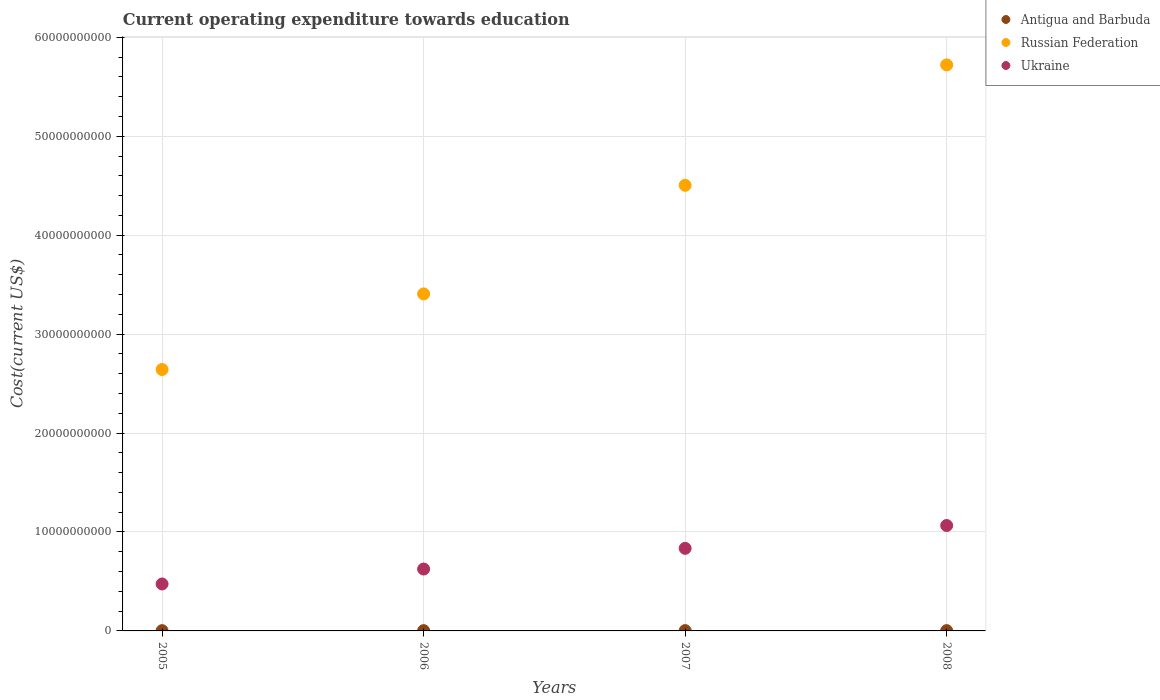How many different coloured dotlines are there?
Provide a succinct answer. 3. Is the number of dotlines equal to the number of legend labels?
Offer a terse response. Yes. What is the expenditure towards education in Russian Federation in 2007?
Your answer should be compact. 4.50e+1. Across all years, what is the maximum expenditure towards education in Antigua and Barbuda?
Provide a succinct answer. 3.09e+07. Across all years, what is the minimum expenditure towards education in Ukraine?
Offer a terse response. 4.75e+09. In which year was the expenditure towards education in Antigua and Barbuda maximum?
Offer a very short reply. 2007. In which year was the expenditure towards education in Russian Federation minimum?
Offer a terse response. 2005. What is the total expenditure towards education in Antigua and Barbuda in the graph?
Provide a short and direct response. 1.18e+08. What is the difference between the expenditure towards education in Antigua and Barbuda in 2005 and that in 2006?
Your answer should be compact. -1.68e+06. What is the difference between the expenditure towards education in Russian Federation in 2006 and the expenditure towards education in Ukraine in 2007?
Ensure brevity in your answer.  2.57e+1. What is the average expenditure towards education in Ukraine per year?
Keep it short and to the point. 7.50e+09. In the year 2005, what is the difference between the expenditure towards education in Antigua and Barbuda and expenditure towards education in Russian Federation?
Your response must be concise. -2.64e+1. What is the ratio of the expenditure towards education in Ukraine in 2005 to that in 2007?
Provide a succinct answer. 0.57. Is the expenditure towards education in Russian Federation in 2005 less than that in 2008?
Offer a very short reply. Yes. Is the difference between the expenditure towards education in Antigua and Barbuda in 2006 and 2008 greater than the difference between the expenditure towards education in Russian Federation in 2006 and 2008?
Offer a very short reply. Yes. What is the difference between the highest and the second highest expenditure towards education in Antigua and Barbuda?
Provide a succinct answer. 1.33e+06. What is the difference between the highest and the lowest expenditure towards education in Ukraine?
Ensure brevity in your answer.  5.91e+09. Is it the case that in every year, the sum of the expenditure towards education in Antigua and Barbuda and expenditure towards education in Russian Federation  is greater than the expenditure towards education in Ukraine?
Keep it short and to the point. Yes. Does the expenditure towards education in Russian Federation monotonically increase over the years?
Provide a succinct answer. Yes. Is the expenditure towards education in Ukraine strictly less than the expenditure towards education in Russian Federation over the years?
Your answer should be very brief. Yes. How many years are there in the graph?
Provide a short and direct response. 4. Where does the legend appear in the graph?
Make the answer very short. Top right. How many legend labels are there?
Offer a very short reply. 3. How are the legend labels stacked?
Give a very brief answer. Vertical. What is the title of the graph?
Make the answer very short. Current operating expenditure towards education. What is the label or title of the Y-axis?
Your response must be concise. Cost(current US$). What is the Cost(current US$) of Antigua and Barbuda in 2005?
Provide a succinct answer. 2.77e+07. What is the Cost(current US$) of Russian Federation in 2005?
Offer a terse response. 2.64e+1. What is the Cost(current US$) of Ukraine in 2005?
Your answer should be very brief. 4.75e+09. What is the Cost(current US$) of Antigua and Barbuda in 2006?
Your answer should be very brief. 2.94e+07. What is the Cost(current US$) in Russian Federation in 2006?
Provide a succinct answer. 3.41e+1. What is the Cost(current US$) of Ukraine in 2006?
Offer a terse response. 6.26e+09. What is the Cost(current US$) of Antigua and Barbuda in 2007?
Offer a terse response. 3.09e+07. What is the Cost(current US$) in Russian Federation in 2007?
Provide a succinct answer. 4.50e+1. What is the Cost(current US$) of Ukraine in 2007?
Keep it short and to the point. 8.35e+09. What is the Cost(current US$) in Antigua and Barbuda in 2008?
Offer a terse response. 2.96e+07. What is the Cost(current US$) in Russian Federation in 2008?
Your answer should be compact. 5.72e+1. What is the Cost(current US$) in Ukraine in 2008?
Provide a succinct answer. 1.07e+1. Across all years, what is the maximum Cost(current US$) in Antigua and Barbuda?
Ensure brevity in your answer.  3.09e+07. Across all years, what is the maximum Cost(current US$) of Russian Federation?
Your answer should be compact. 5.72e+1. Across all years, what is the maximum Cost(current US$) in Ukraine?
Give a very brief answer. 1.07e+1. Across all years, what is the minimum Cost(current US$) of Antigua and Barbuda?
Your response must be concise. 2.77e+07. Across all years, what is the minimum Cost(current US$) in Russian Federation?
Provide a short and direct response. 2.64e+1. Across all years, what is the minimum Cost(current US$) in Ukraine?
Provide a short and direct response. 4.75e+09. What is the total Cost(current US$) of Antigua and Barbuda in the graph?
Your response must be concise. 1.18e+08. What is the total Cost(current US$) of Russian Federation in the graph?
Provide a short and direct response. 1.63e+11. What is the total Cost(current US$) in Ukraine in the graph?
Offer a very short reply. 3.00e+1. What is the difference between the Cost(current US$) in Antigua and Barbuda in 2005 and that in 2006?
Offer a very short reply. -1.68e+06. What is the difference between the Cost(current US$) in Russian Federation in 2005 and that in 2006?
Offer a very short reply. -7.64e+09. What is the difference between the Cost(current US$) of Ukraine in 2005 and that in 2006?
Offer a very short reply. -1.51e+09. What is the difference between the Cost(current US$) in Antigua and Barbuda in 2005 and that in 2007?
Ensure brevity in your answer.  -3.21e+06. What is the difference between the Cost(current US$) in Russian Federation in 2005 and that in 2007?
Keep it short and to the point. -1.86e+1. What is the difference between the Cost(current US$) of Ukraine in 2005 and that in 2007?
Provide a short and direct response. -3.60e+09. What is the difference between the Cost(current US$) of Antigua and Barbuda in 2005 and that in 2008?
Make the answer very short. -1.88e+06. What is the difference between the Cost(current US$) in Russian Federation in 2005 and that in 2008?
Your answer should be compact. -3.08e+1. What is the difference between the Cost(current US$) in Ukraine in 2005 and that in 2008?
Your answer should be very brief. -5.91e+09. What is the difference between the Cost(current US$) in Antigua and Barbuda in 2006 and that in 2007?
Provide a succinct answer. -1.53e+06. What is the difference between the Cost(current US$) in Russian Federation in 2006 and that in 2007?
Your answer should be very brief. -1.10e+1. What is the difference between the Cost(current US$) in Ukraine in 2006 and that in 2007?
Provide a succinct answer. -2.09e+09. What is the difference between the Cost(current US$) of Antigua and Barbuda in 2006 and that in 2008?
Your response must be concise. -1.97e+05. What is the difference between the Cost(current US$) of Russian Federation in 2006 and that in 2008?
Offer a very short reply. -2.32e+1. What is the difference between the Cost(current US$) in Ukraine in 2006 and that in 2008?
Your response must be concise. -4.40e+09. What is the difference between the Cost(current US$) in Antigua and Barbuda in 2007 and that in 2008?
Your answer should be compact. 1.33e+06. What is the difference between the Cost(current US$) of Russian Federation in 2007 and that in 2008?
Provide a succinct answer. -1.22e+1. What is the difference between the Cost(current US$) of Ukraine in 2007 and that in 2008?
Provide a succinct answer. -2.31e+09. What is the difference between the Cost(current US$) in Antigua and Barbuda in 2005 and the Cost(current US$) in Russian Federation in 2006?
Your response must be concise. -3.40e+1. What is the difference between the Cost(current US$) in Antigua and Barbuda in 2005 and the Cost(current US$) in Ukraine in 2006?
Keep it short and to the point. -6.23e+09. What is the difference between the Cost(current US$) in Russian Federation in 2005 and the Cost(current US$) in Ukraine in 2006?
Provide a short and direct response. 2.02e+1. What is the difference between the Cost(current US$) of Antigua and Barbuda in 2005 and the Cost(current US$) of Russian Federation in 2007?
Offer a terse response. -4.50e+1. What is the difference between the Cost(current US$) of Antigua and Barbuda in 2005 and the Cost(current US$) of Ukraine in 2007?
Your answer should be compact. -8.32e+09. What is the difference between the Cost(current US$) of Russian Federation in 2005 and the Cost(current US$) of Ukraine in 2007?
Provide a succinct answer. 1.81e+1. What is the difference between the Cost(current US$) of Antigua and Barbuda in 2005 and the Cost(current US$) of Russian Federation in 2008?
Offer a terse response. -5.72e+1. What is the difference between the Cost(current US$) in Antigua and Barbuda in 2005 and the Cost(current US$) in Ukraine in 2008?
Provide a short and direct response. -1.06e+1. What is the difference between the Cost(current US$) of Russian Federation in 2005 and the Cost(current US$) of Ukraine in 2008?
Give a very brief answer. 1.58e+1. What is the difference between the Cost(current US$) of Antigua and Barbuda in 2006 and the Cost(current US$) of Russian Federation in 2007?
Keep it short and to the point. -4.50e+1. What is the difference between the Cost(current US$) of Antigua and Barbuda in 2006 and the Cost(current US$) of Ukraine in 2007?
Provide a short and direct response. -8.32e+09. What is the difference between the Cost(current US$) of Russian Federation in 2006 and the Cost(current US$) of Ukraine in 2007?
Give a very brief answer. 2.57e+1. What is the difference between the Cost(current US$) in Antigua and Barbuda in 2006 and the Cost(current US$) in Russian Federation in 2008?
Ensure brevity in your answer.  -5.72e+1. What is the difference between the Cost(current US$) of Antigua and Barbuda in 2006 and the Cost(current US$) of Ukraine in 2008?
Make the answer very short. -1.06e+1. What is the difference between the Cost(current US$) of Russian Federation in 2006 and the Cost(current US$) of Ukraine in 2008?
Your response must be concise. 2.34e+1. What is the difference between the Cost(current US$) in Antigua and Barbuda in 2007 and the Cost(current US$) in Russian Federation in 2008?
Ensure brevity in your answer.  -5.72e+1. What is the difference between the Cost(current US$) of Antigua and Barbuda in 2007 and the Cost(current US$) of Ukraine in 2008?
Your answer should be compact. -1.06e+1. What is the difference between the Cost(current US$) in Russian Federation in 2007 and the Cost(current US$) in Ukraine in 2008?
Your answer should be very brief. 3.44e+1. What is the average Cost(current US$) of Antigua and Barbuda per year?
Give a very brief answer. 2.94e+07. What is the average Cost(current US$) of Russian Federation per year?
Your answer should be very brief. 4.07e+1. What is the average Cost(current US$) of Ukraine per year?
Provide a short and direct response. 7.50e+09. In the year 2005, what is the difference between the Cost(current US$) of Antigua and Barbuda and Cost(current US$) of Russian Federation?
Provide a short and direct response. -2.64e+1. In the year 2005, what is the difference between the Cost(current US$) in Antigua and Barbuda and Cost(current US$) in Ukraine?
Your answer should be compact. -4.72e+09. In the year 2005, what is the difference between the Cost(current US$) in Russian Federation and Cost(current US$) in Ukraine?
Your response must be concise. 2.17e+1. In the year 2006, what is the difference between the Cost(current US$) of Antigua and Barbuda and Cost(current US$) of Russian Federation?
Your answer should be very brief. -3.40e+1. In the year 2006, what is the difference between the Cost(current US$) in Antigua and Barbuda and Cost(current US$) in Ukraine?
Offer a very short reply. -6.23e+09. In the year 2006, what is the difference between the Cost(current US$) in Russian Federation and Cost(current US$) in Ukraine?
Provide a succinct answer. 2.78e+1. In the year 2007, what is the difference between the Cost(current US$) of Antigua and Barbuda and Cost(current US$) of Russian Federation?
Offer a terse response. -4.50e+1. In the year 2007, what is the difference between the Cost(current US$) of Antigua and Barbuda and Cost(current US$) of Ukraine?
Provide a short and direct response. -8.31e+09. In the year 2007, what is the difference between the Cost(current US$) in Russian Federation and Cost(current US$) in Ukraine?
Your answer should be very brief. 3.67e+1. In the year 2008, what is the difference between the Cost(current US$) in Antigua and Barbuda and Cost(current US$) in Russian Federation?
Make the answer very short. -5.72e+1. In the year 2008, what is the difference between the Cost(current US$) of Antigua and Barbuda and Cost(current US$) of Ukraine?
Keep it short and to the point. -1.06e+1. In the year 2008, what is the difference between the Cost(current US$) of Russian Federation and Cost(current US$) of Ukraine?
Your answer should be compact. 4.66e+1. What is the ratio of the Cost(current US$) in Antigua and Barbuda in 2005 to that in 2006?
Ensure brevity in your answer.  0.94. What is the ratio of the Cost(current US$) of Russian Federation in 2005 to that in 2006?
Offer a very short reply. 0.78. What is the ratio of the Cost(current US$) of Ukraine in 2005 to that in 2006?
Your answer should be very brief. 0.76. What is the ratio of the Cost(current US$) in Antigua and Barbuda in 2005 to that in 2007?
Ensure brevity in your answer.  0.9. What is the ratio of the Cost(current US$) in Russian Federation in 2005 to that in 2007?
Your response must be concise. 0.59. What is the ratio of the Cost(current US$) in Ukraine in 2005 to that in 2007?
Keep it short and to the point. 0.57. What is the ratio of the Cost(current US$) of Antigua and Barbuda in 2005 to that in 2008?
Provide a succinct answer. 0.94. What is the ratio of the Cost(current US$) in Russian Federation in 2005 to that in 2008?
Give a very brief answer. 0.46. What is the ratio of the Cost(current US$) of Ukraine in 2005 to that in 2008?
Keep it short and to the point. 0.45. What is the ratio of the Cost(current US$) in Antigua and Barbuda in 2006 to that in 2007?
Keep it short and to the point. 0.95. What is the ratio of the Cost(current US$) of Russian Federation in 2006 to that in 2007?
Your response must be concise. 0.76. What is the ratio of the Cost(current US$) of Ukraine in 2006 to that in 2007?
Your response must be concise. 0.75. What is the ratio of the Cost(current US$) of Antigua and Barbuda in 2006 to that in 2008?
Give a very brief answer. 0.99. What is the ratio of the Cost(current US$) of Russian Federation in 2006 to that in 2008?
Provide a short and direct response. 0.6. What is the ratio of the Cost(current US$) of Ukraine in 2006 to that in 2008?
Provide a succinct answer. 0.59. What is the ratio of the Cost(current US$) of Antigua and Barbuda in 2007 to that in 2008?
Your answer should be very brief. 1.04. What is the ratio of the Cost(current US$) of Russian Federation in 2007 to that in 2008?
Provide a succinct answer. 0.79. What is the ratio of the Cost(current US$) in Ukraine in 2007 to that in 2008?
Give a very brief answer. 0.78. What is the difference between the highest and the second highest Cost(current US$) of Antigua and Barbuda?
Keep it short and to the point. 1.33e+06. What is the difference between the highest and the second highest Cost(current US$) in Russian Federation?
Offer a terse response. 1.22e+1. What is the difference between the highest and the second highest Cost(current US$) in Ukraine?
Offer a terse response. 2.31e+09. What is the difference between the highest and the lowest Cost(current US$) of Antigua and Barbuda?
Offer a terse response. 3.21e+06. What is the difference between the highest and the lowest Cost(current US$) in Russian Federation?
Provide a succinct answer. 3.08e+1. What is the difference between the highest and the lowest Cost(current US$) of Ukraine?
Offer a terse response. 5.91e+09. 